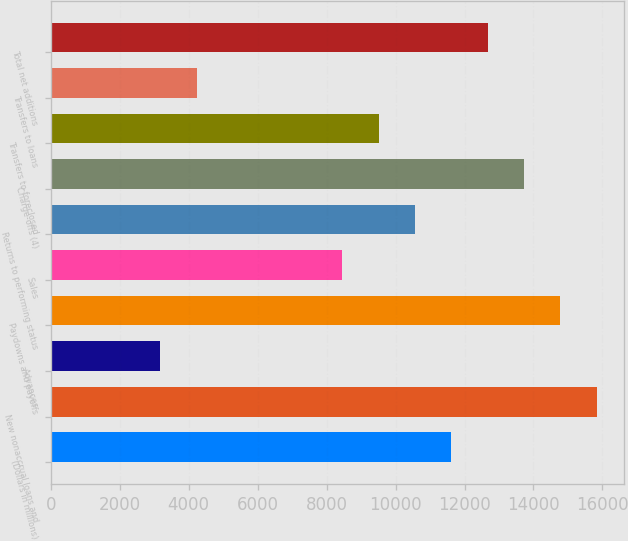Convert chart to OTSL. <chart><loc_0><loc_0><loc_500><loc_500><bar_chart><fcel>(Dollars in millions)<fcel>New nonaccrual loans and<fcel>Advances<fcel>Paydowns and payoffs<fcel>Sales<fcel>Returns to performing status<fcel>Charge-offs (4)<fcel>Transfers to foreclosed<fcel>Transfers to loans<fcel>Total net additions<nl><fcel>11616.8<fcel>15839.8<fcel>3170.65<fcel>14784.1<fcel>8449.49<fcel>10561<fcel>13728.3<fcel>9505.25<fcel>4226.41<fcel>12672.5<nl></chart> 